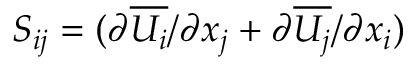<formula> <loc_0><loc_0><loc_500><loc_500>S _ { i j } = ( { \partial \overline { { U _ { i } } } / \partial x _ { j } } + { \partial \overline { { U _ { j } } } / \partial x _ { i } } )</formula> 